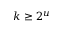Convert formula to latex. <formula><loc_0><loc_0><loc_500><loc_500>k \geq 2 ^ { u }</formula> 